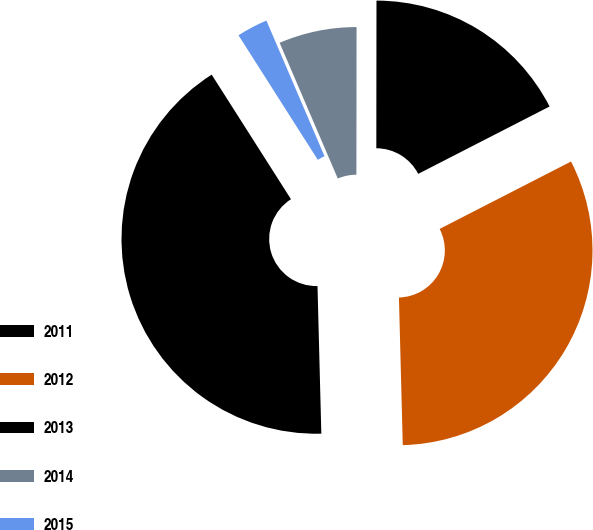Convert chart to OTSL. <chart><loc_0><loc_0><loc_500><loc_500><pie_chart><fcel>2011<fcel>2012<fcel>2013<fcel>2014<fcel>2015<nl><fcel>41.39%<fcel>32.13%<fcel>17.44%<fcel>6.46%<fcel>2.58%<nl></chart> 